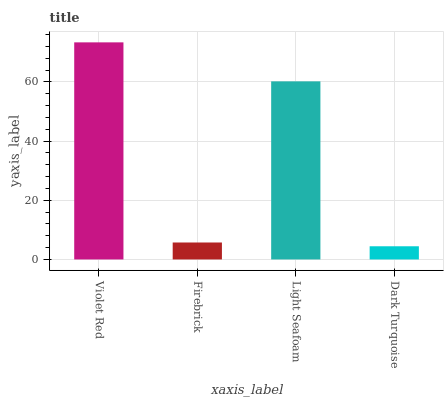Is Dark Turquoise the minimum?
Answer yes or no. Yes. Is Violet Red the maximum?
Answer yes or no. Yes. Is Firebrick the minimum?
Answer yes or no. No. Is Firebrick the maximum?
Answer yes or no. No. Is Violet Red greater than Firebrick?
Answer yes or no. Yes. Is Firebrick less than Violet Red?
Answer yes or no. Yes. Is Firebrick greater than Violet Red?
Answer yes or no. No. Is Violet Red less than Firebrick?
Answer yes or no. No. Is Light Seafoam the high median?
Answer yes or no. Yes. Is Firebrick the low median?
Answer yes or no. Yes. Is Violet Red the high median?
Answer yes or no. No. Is Light Seafoam the low median?
Answer yes or no. No. 